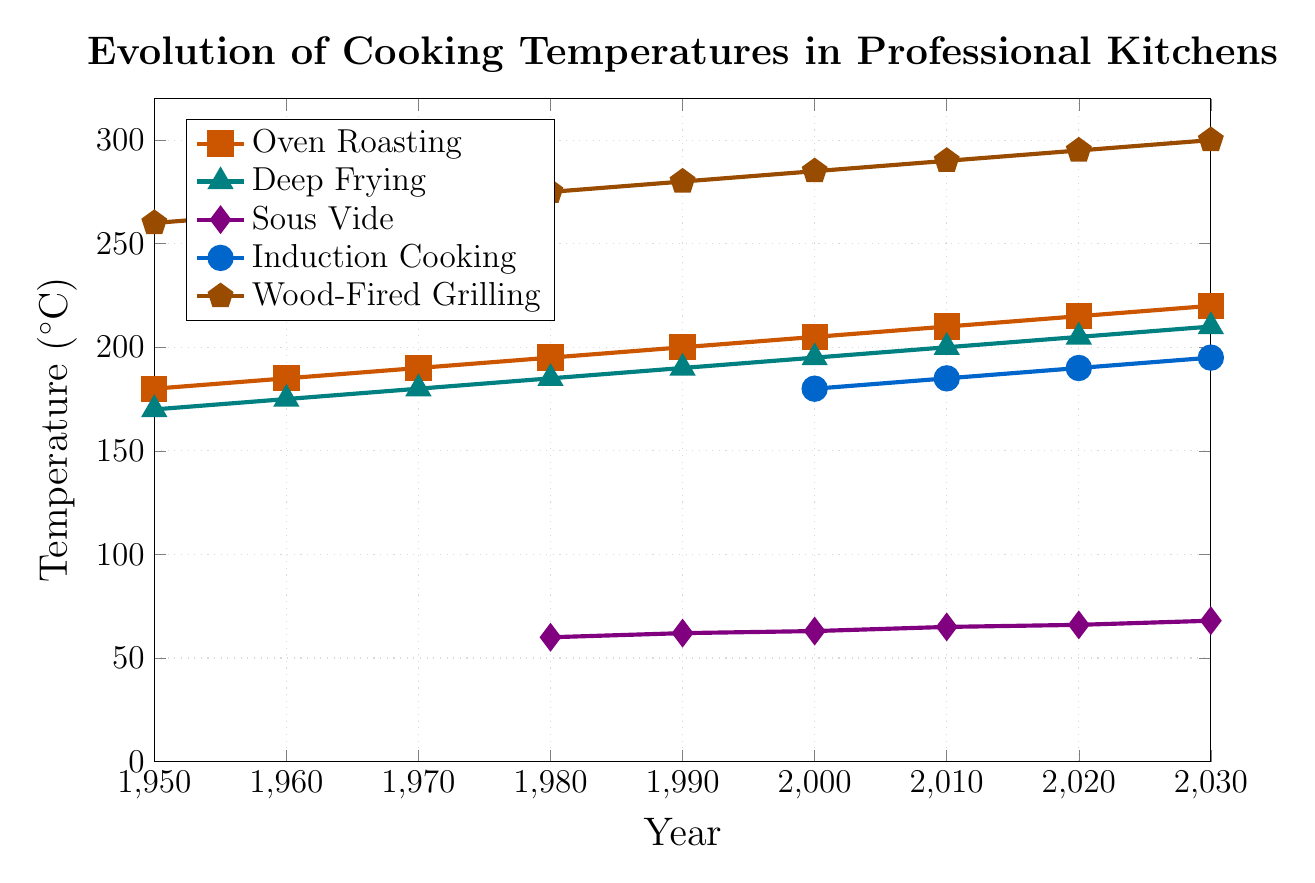What year did Sous Vide cooking first appear on the chart? Sous Vide cooking first appears on the chart with a temperature value in 1980
Answer: 1980 Which cooking method shows the highest temperature in 2030? In 2030, the highest temperature is shown by Wood-Fired Grilling at 300°C
Answer: Wood-Fired Grilling What is the overall trend of Oven Roasting temperatures from 1950 to 2030? The trend for Oven Roasting temperatures shows a steady increase from 180°C in 1950 to 220°C in 2030
Answer: Steady increase Which cooking method remained the most consistent in temperature from 1980 to 2030? Comparing the fluctuations in temperature, Sous Vide remained the most consistent with a small increase from 60°C in 1980 to 68°C in 2030
Answer: Sous Vide How does the temperature for Deep Frying in 1990 compare to that of Oven Roasting in the same year? In 1990, Deep Frying is at 190°C, whereas Oven Roasting is at 200°C, making Oven Roasting 10°C higher than Deep Frying
Answer: Oven Roasting is 10°C higher What is the average temperature of Induction Cooking over the years it appears (2000 to 2030)? The temperatures for Induction Cooking over the years 2000 to 2030 are: 180, 185, 190, 195. Summing these gives 750°C, and dividing by 4 gives an average of 187.5°C
Answer: 187.5°C Compare the temperature increase of Wood-Fired Grilling and Deep Frying from 1950 to 2030. For Wood-Fired Grilling, the temperature increases from 260°C in 1950 to 300°C in 2030, an increase of 40°C. For Deep Frying, the temperature increases from 170°C in 1950 to 210°C in 2030, an increase of 40°C
Answer: Both increased by 40°C What is the median temperature for Oven Roasting across all years? The temperatures for Oven Roasting are: 180, 185, 190, 195, 200, 205, 210, 215, 220. The median is the 5th number in this ordered list, which is 200°C
Answer: 200°C How does the introduction of Induction Cooking in 2000 affect the overall trend of temperature variations? Induction Cooking appears starting in 2000 and adds temperatures that are relatively high (from 180°C to 195°C), contributing to an overall trend of slightly higher cooking temperatures over time
Answer: Slight increase in overall trends What is the total increase in temperature for Oven Roasting from 1950 to 2030? The temperature for Oven Roasting increases from 180°C in 1950 to 220°C in 2030. Therefore, the total increase is 220°C - 180°C = 40°C
Answer: 40°C 